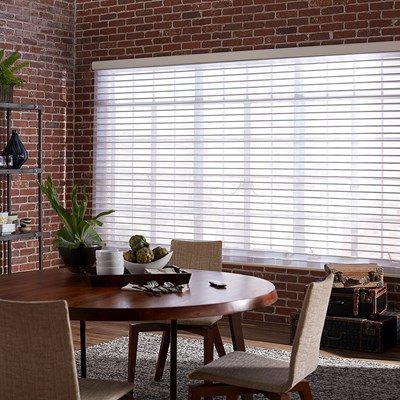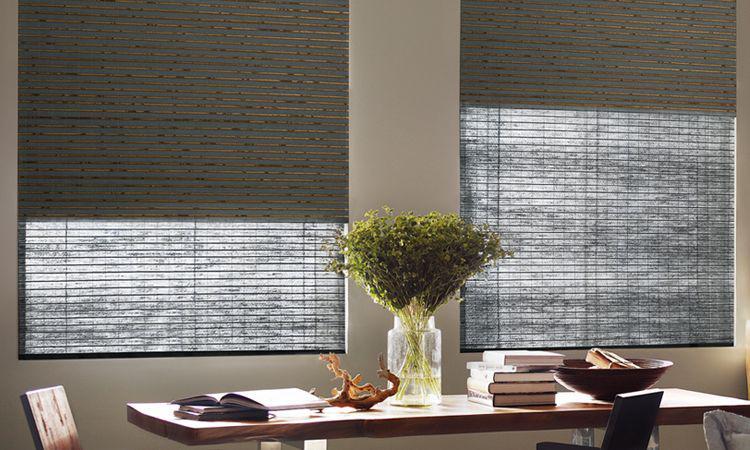The first image is the image on the left, the second image is the image on the right. For the images shown, is this caption "There are exactly two window shades in the right image." true? Answer yes or no. Yes. 